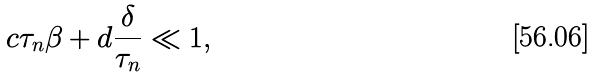Convert formula to latex. <formula><loc_0><loc_0><loc_500><loc_500>c \tau _ { n } \beta + d \frac { \delta } { \tau _ { n } } \ll 1 ,</formula> 